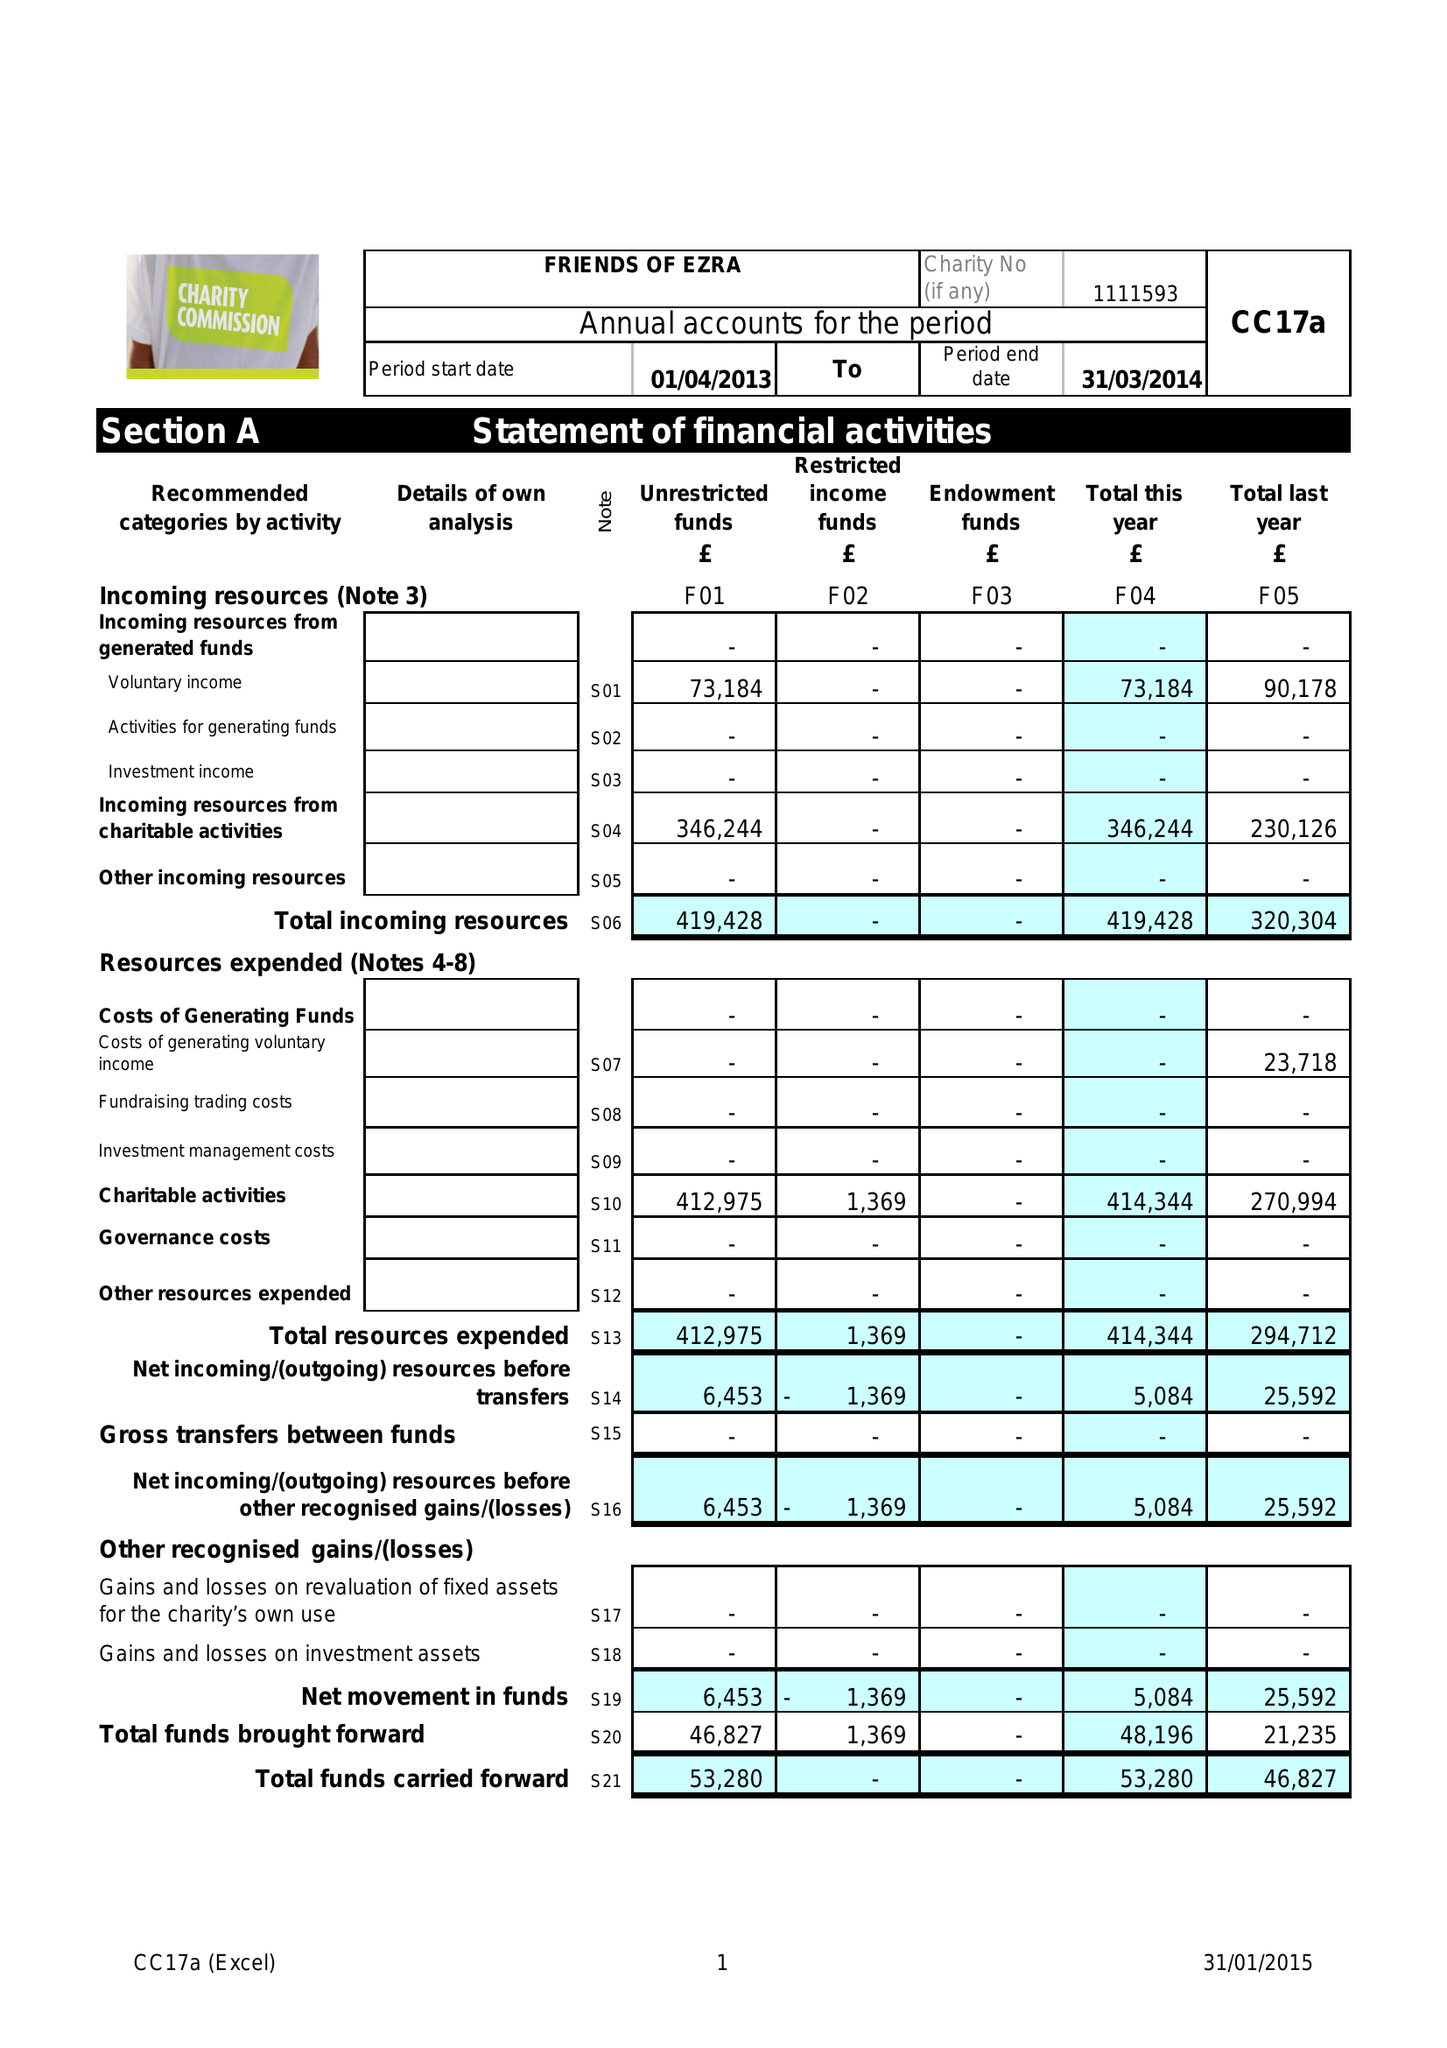What is the value for the address__post_town?
Answer the question using a single word or phrase. LONDON 